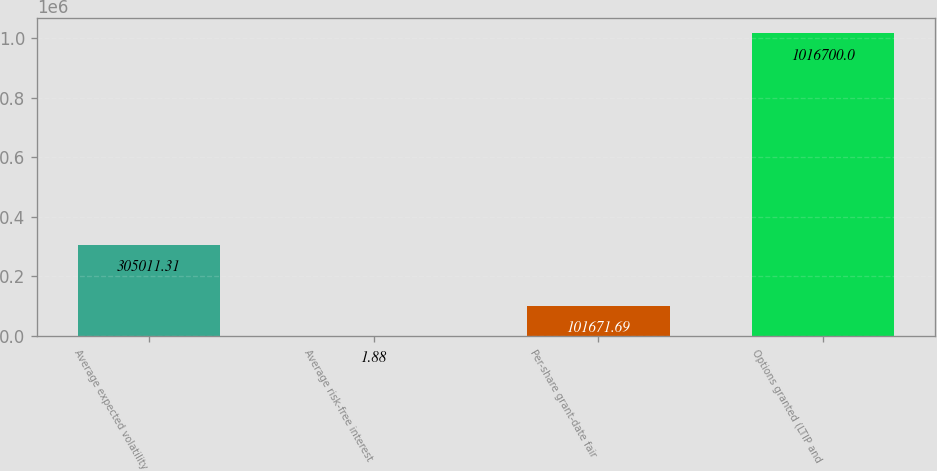Convert chart. <chart><loc_0><loc_0><loc_500><loc_500><bar_chart><fcel>Average expected volatility<fcel>Average risk-free interest<fcel>Per-share grant-date fair<fcel>Options granted (LTIP and<nl><fcel>305011<fcel>1.88<fcel>101672<fcel>1.0167e+06<nl></chart> 